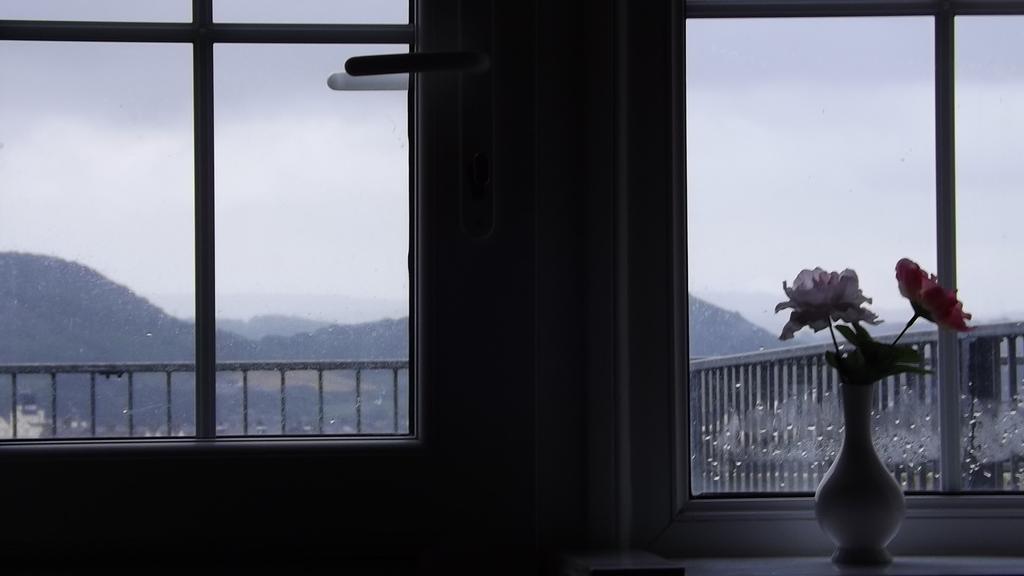Could you give a brief overview of what you see in this image? In this image there is a flower vase on the object , and at the background there are windows, buildings, iron grills, hills, sky. 